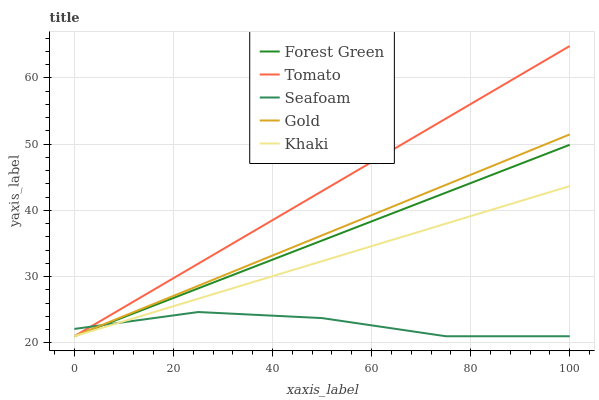Does Seafoam have the minimum area under the curve?
Answer yes or no. Yes. Does Tomato have the maximum area under the curve?
Answer yes or no. Yes. Does Forest Green have the minimum area under the curve?
Answer yes or no. No. Does Forest Green have the maximum area under the curve?
Answer yes or no. No. Is Gold the smoothest?
Answer yes or no. Yes. Is Seafoam the roughest?
Answer yes or no. Yes. Is Forest Green the smoothest?
Answer yes or no. No. Is Forest Green the roughest?
Answer yes or no. No. Does Tomato have the lowest value?
Answer yes or no. Yes. Does Tomato have the highest value?
Answer yes or no. Yes. Does Forest Green have the highest value?
Answer yes or no. No. Does Gold intersect Tomato?
Answer yes or no. Yes. Is Gold less than Tomato?
Answer yes or no. No. Is Gold greater than Tomato?
Answer yes or no. No. 